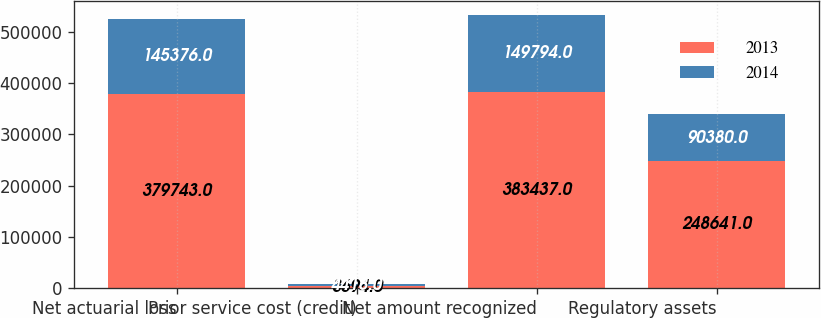<chart> <loc_0><loc_0><loc_500><loc_500><stacked_bar_chart><ecel><fcel>Net actuarial loss<fcel>Prior service cost (credit)<fcel>Net amount recognized<fcel>Regulatory assets<nl><fcel>2013<fcel>379743<fcel>3694<fcel>383437<fcel>248641<nl><fcel>2014<fcel>145376<fcel>4418<fcel>149794<fcel>90380<nl></chart> 